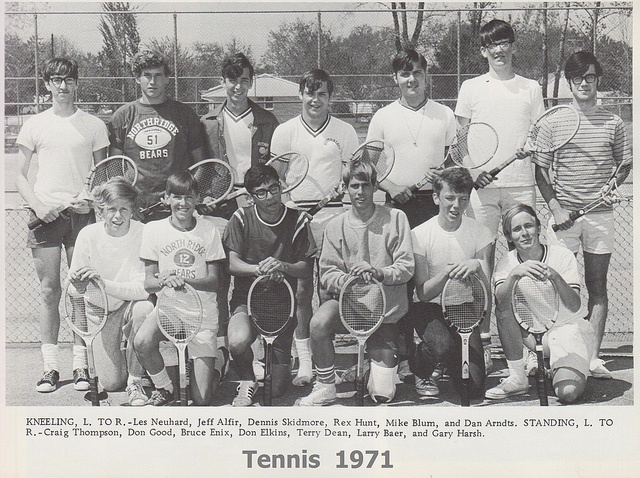Describe the objects in this image and their specific colors. I can see tennis racket in lightgray, gray, and darkgray tones, people in lightgray, darkgray, and gray tones, people in lightgray, darkgray, and gray tones, people in lightgray, gray, and darkgray tones, and people in lightgray, gray, darkgray, and black tones in this image. 